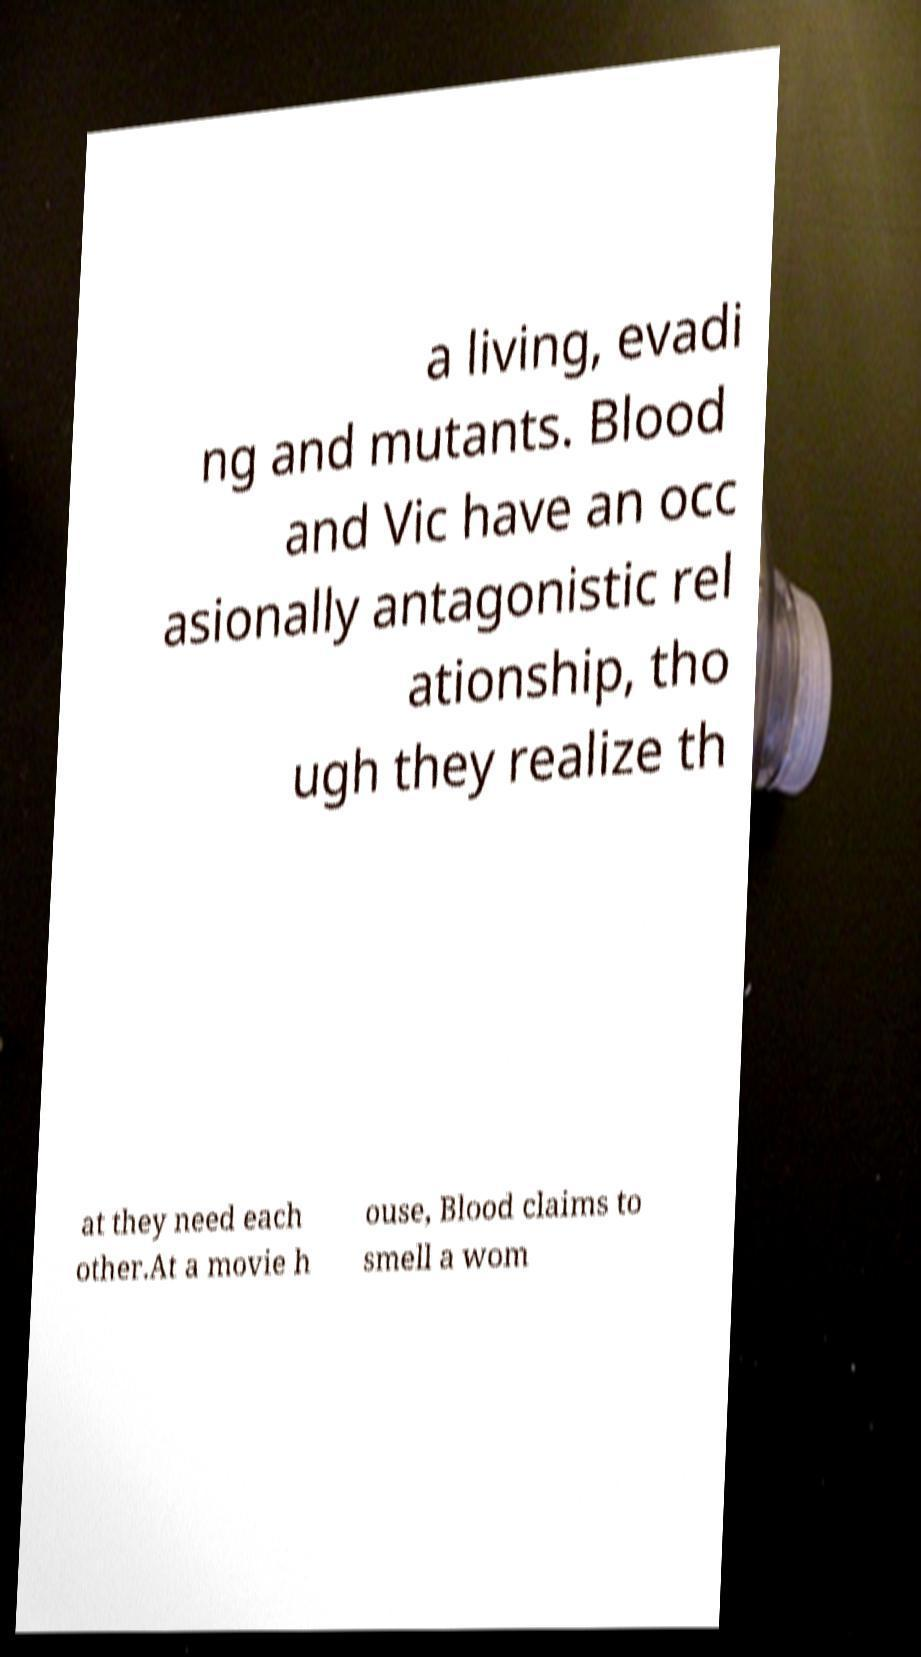What messages or text are displayed in this image? I need them in a readable, typed format. a living, evadi ng and mutants. Blood and Vic have an occ asionally antagonistic rel ationship, tho ugh they realize th at they need each other.At a movie h ouse, Blood claims to smell a wom 